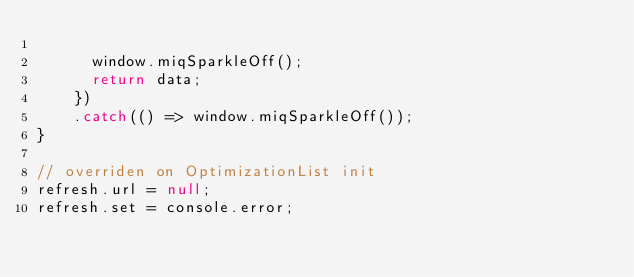Convert code to text. <code><loc_0><loc_0><loc_500><loc_500><_JavaScript_>
      window.miqSparkleOff();
      return data;
    })
    .catch(() => window.miqSparkleOff());
}

// overriden on OptimizationList init
refresh.url = null;
refresh.set = console.error;
</code> 